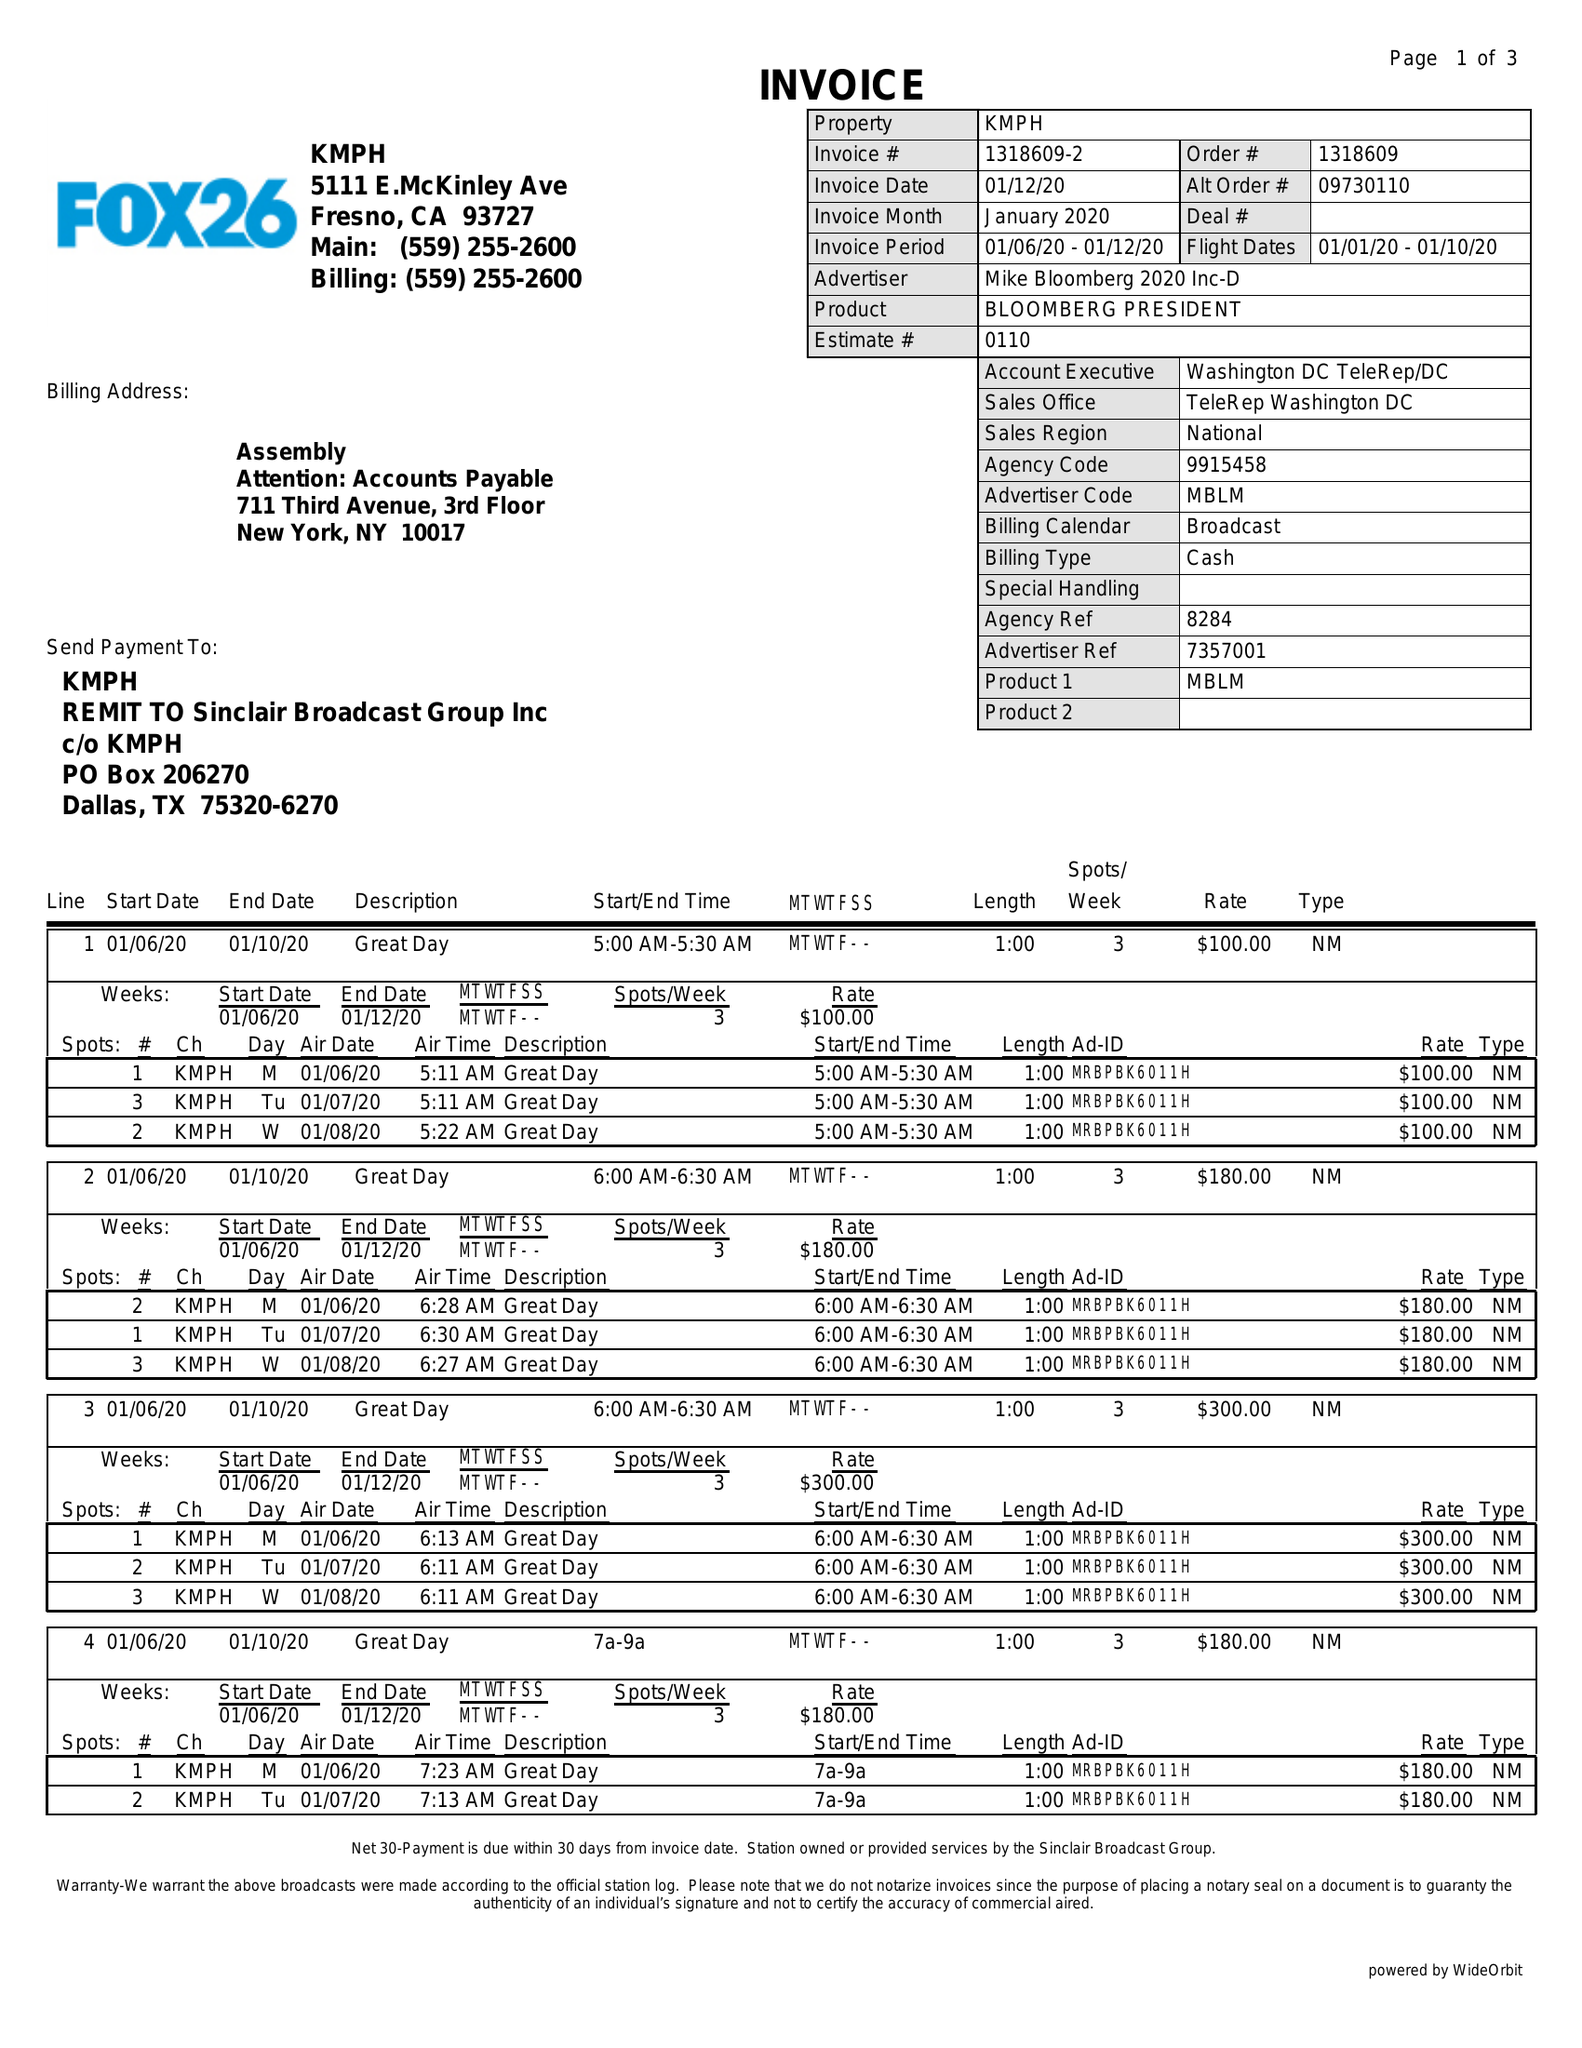What is the value for the contract_num?
Answer the question using a single word or phrase. 1318609 